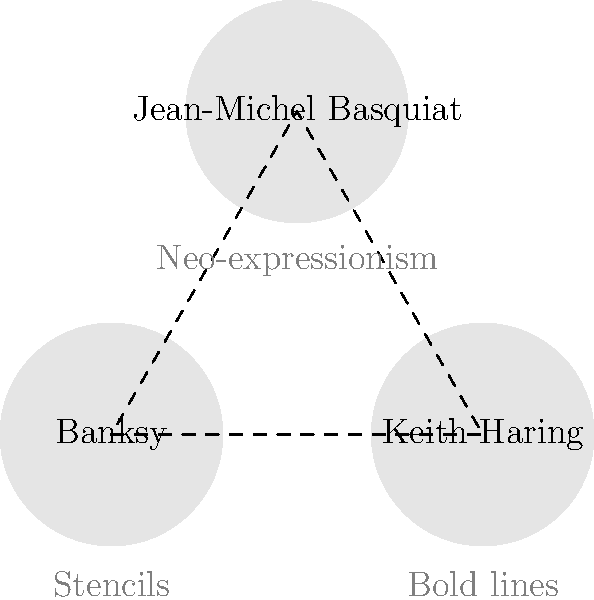Match the street artists to their signature techniques based on the visual representation above. Which artist is known for using stencils in their work? To answer this question, let's analyze the information provided in the graphic:

1. The graphic shows three artists connected in a triangle formation.
2. Each artist is represented by a circle containing their name and their signature technique below.
3. The three artists and techniques shown are:
   a. Banksy - Stencils
   b. Keith Haring - Bold lines
   c. Jean-Michel Basquiat - Neo-expressionism
4. The question specifically asks about the artist known for using stencils.
5. Looking at the information provided, we can see that Banksy is associated with the technique of stencils.

Therefore, the artist known for using stencils in their work is Banksy.
Answer: Banksy 